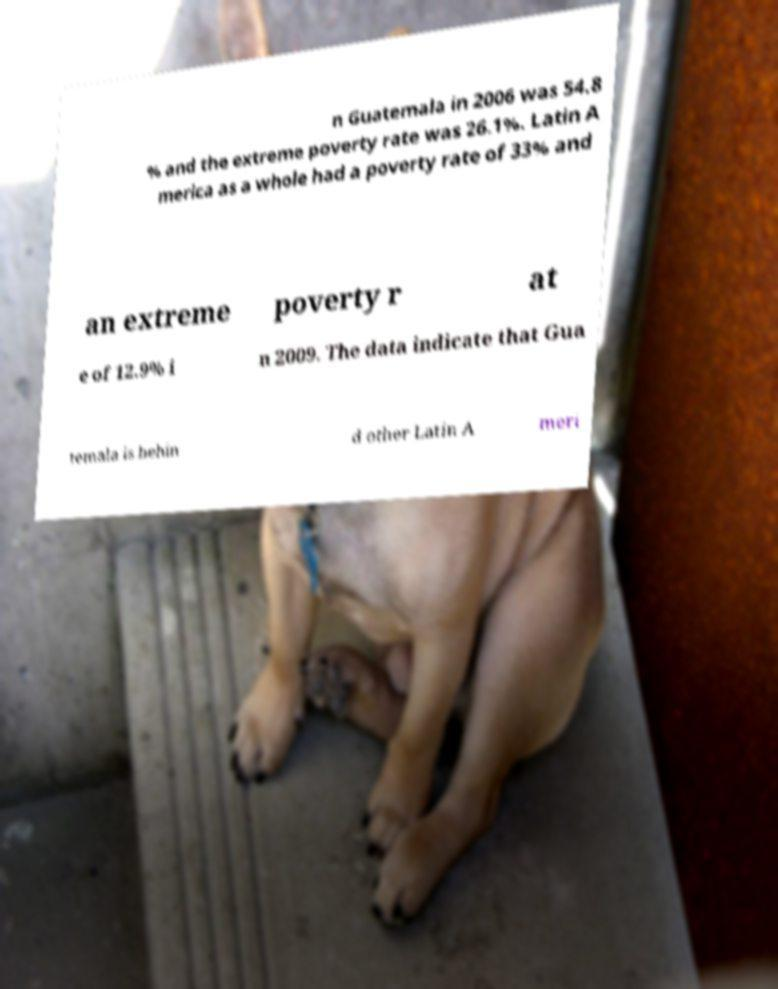Could you extract and type out the text from this image? n Guatemala in 2006 was 54.8 % and the extreme poverty rate was 26.1%. Latin A merica as a whole had a poverty rate of 33% and an extreme poverty r at e of 12.9% i n 2009. The data indicate that Gua temala is behin d other Latin A meri 